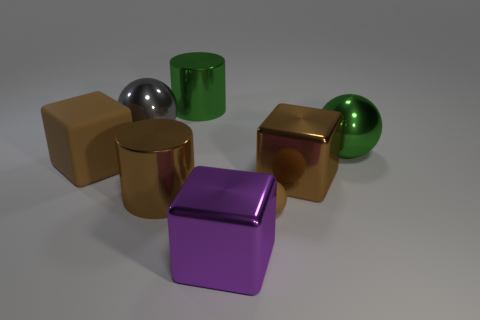Subtract all big brown cubes. How many cubes are left? 1 Add 2 big blue matte cylinders. How many objects exist? 10 Subtract all brown cylinders. How many cylinders are left? 1 Subtract 1 cubes. How many cubes are left? 2 Subtract all cylinders. How many objects are left? 6 Subtract all cyan cylinders. Subtract all blue cubes. How many cylinders are left? 2 Subtract all yellow cubes. How many brown cylinders are left? 1 Subtract all big purple cubes. Subtract all large gray cylinders. How many objects are left? 7 Add 4 gray metallic objects. How many gray metallic objects are left? 5 Add 3 brown shiny blocks. How many brown shiny blocks exist? 4 